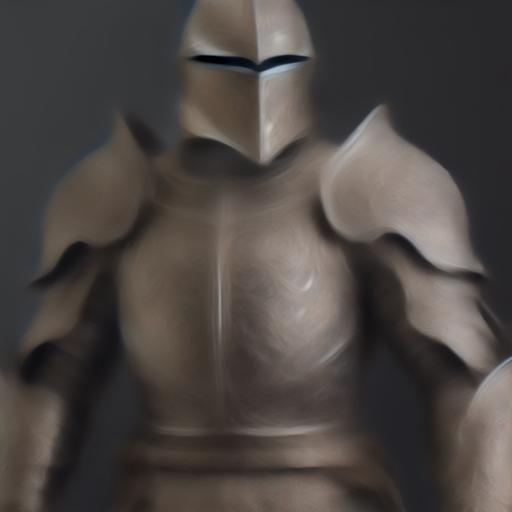Are there any quality issues with this image? Yes, the image appears to be blurred, which affects its clarity and level of detail. This diminished sharpness could be due to a low resolution, motion during the capture process, or post-processing effects. Consequently, it's challenging to discern finer features and textures that might be present in the subject's attire or background. 